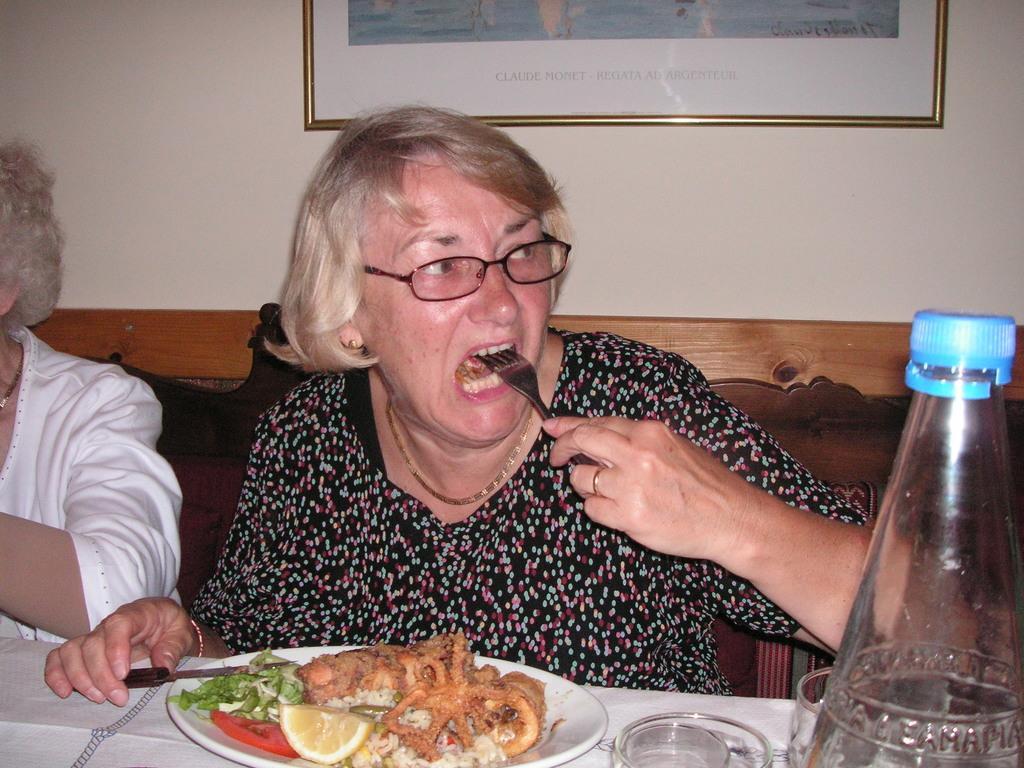Can you describe this image briefly? In this image i can see a woman sitting and eating, there is a food in a plate, a glass ,a bottle on a table at left there is other person sitting at the back ground i can see a frame attached to a wall. 